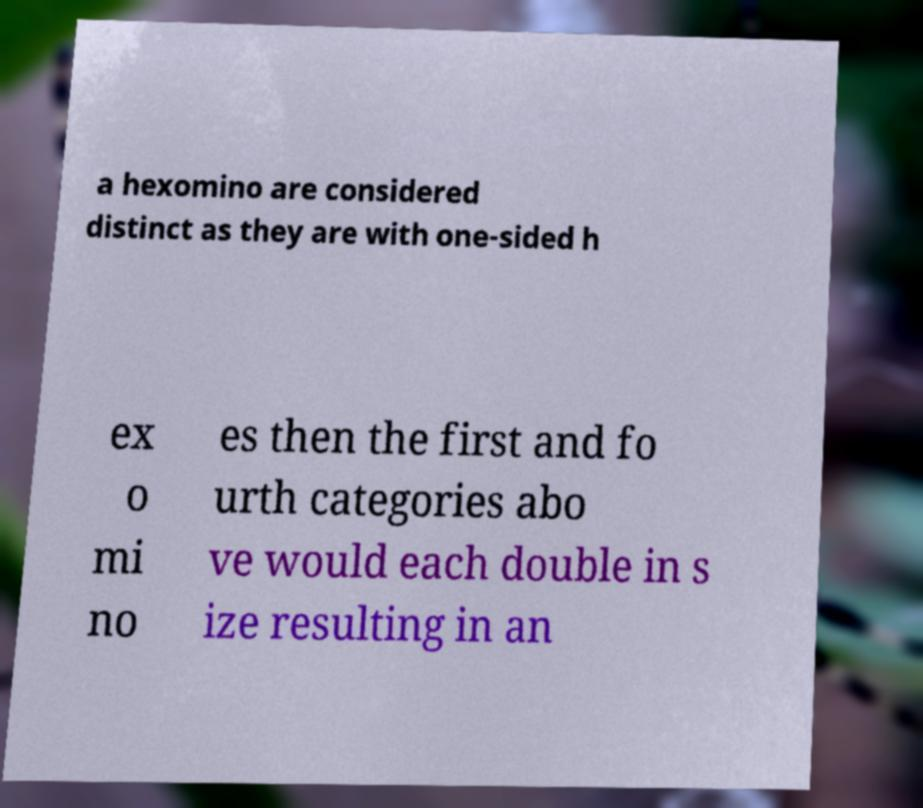Can you read and provide the text displayed in the image?This photo seems to have some interesting text. Can you extract and type it out for me? a hexomino are considered distinct as they are with one-sided h ex o mi no es then the first and fo urth categories abo ve would each double in s ize resulting in an 